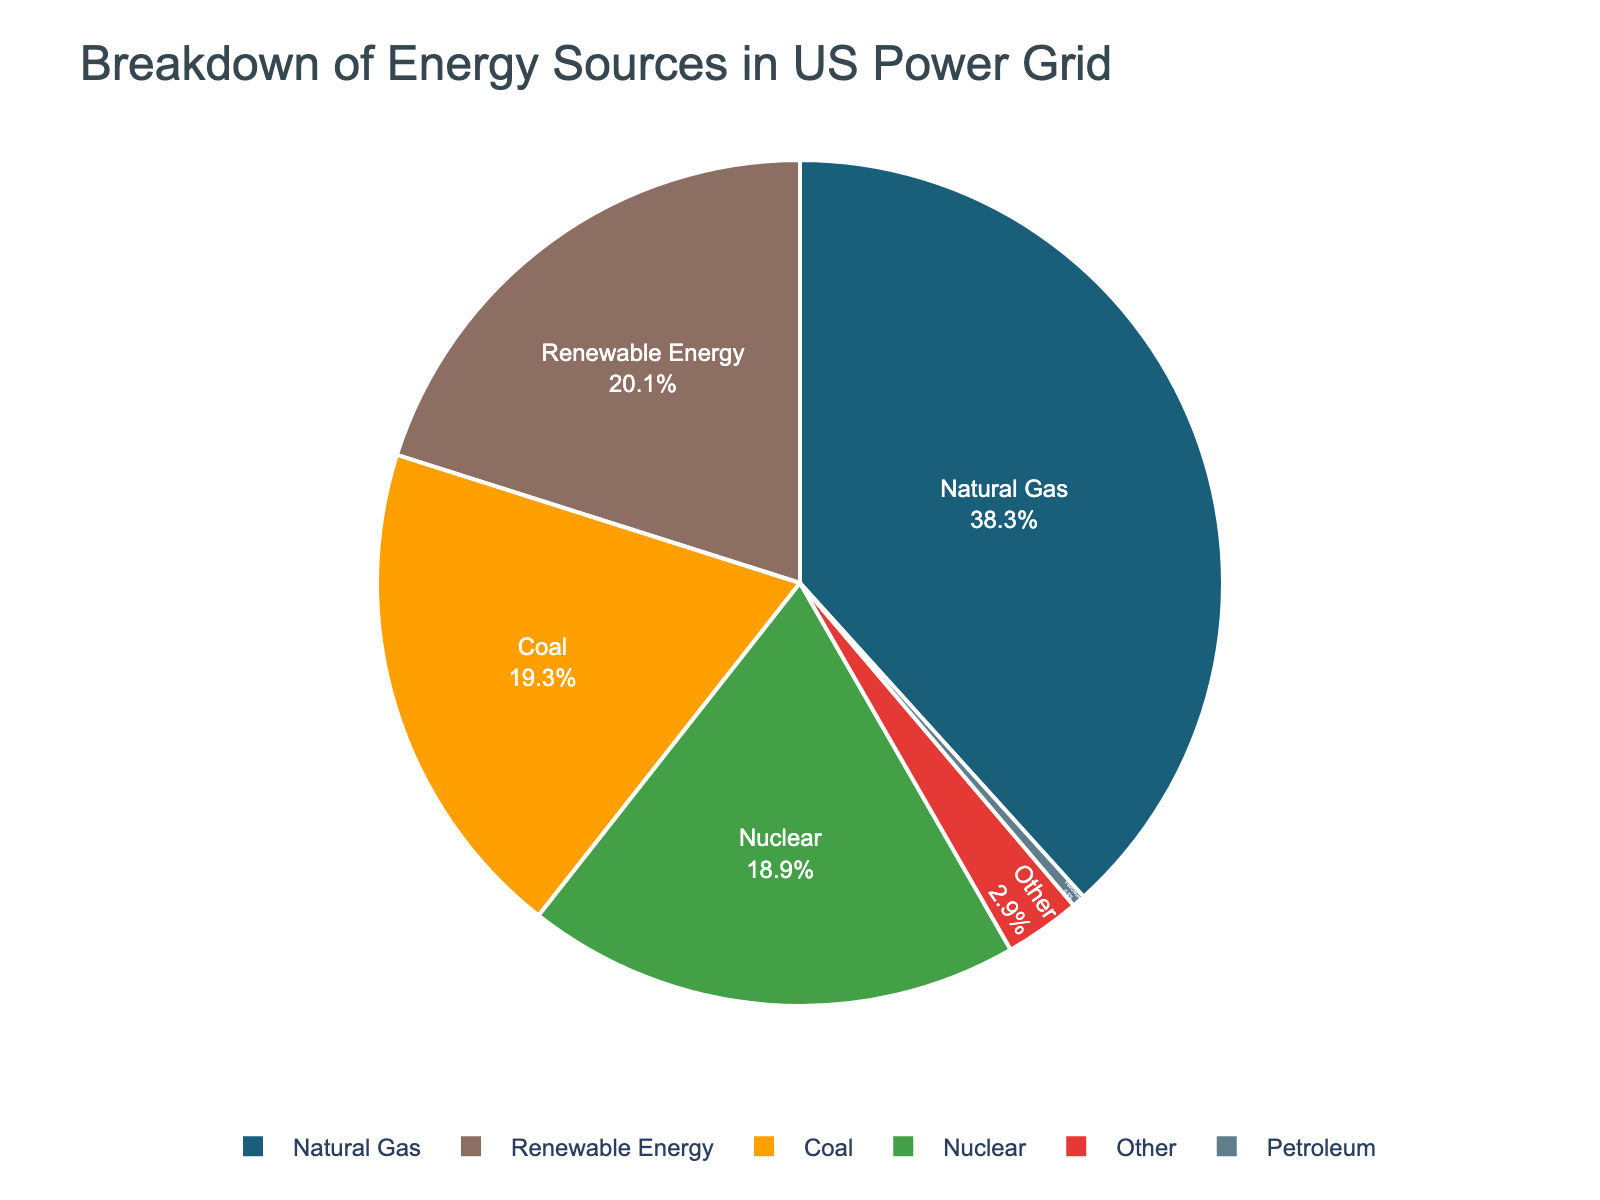What's the predominant energy source in the US power grid? By looking at the pie chart, identify which segment represents more than the others based on its size and color. Here, Natural Gas occupies the largest segment.
Answer: Natural Gas What's the combined percentage of energy provided by Coal and Nuclear sources? Add the percentages of Coal and Nuclear sources from the pie chart: 19.3% (Coal) + 18.9% (Nuclear).
Answer: 38.2% Which energy source contributes the least to the US power grid? Look for the smallest slice in the pie chart. The slice representing Petroleum is the smallest with 0.5%.
Answer: Petroleum How much more does Renewable Energy contribute compared to Coal? Subtract the percentage of Coal from the percentage of Renewable Energy: 20.1% - 19.3%.
Answer: 0.8% What is the total percentage of non-renewable energy sources (Natural Gas, Coal, Petroleum, Other)? Add the percentages of Natural Gas, Coal, Petroleum, and Other: 38.3% + 19.3% + 0.5% + 2.9%.
Answer: 61.0% Which energy source is closest in contribution to Nuclear Energy? Compare percentage values of all sources to Nuclear (18.9%). Renewable Energy (20.1%) is the closest to Nuclear Energy.
Answer: Renewable Energy Among Renewable Energy and Natural Gas, which one has a higher contribution and by how much? Subtract the percentage of Renewable Energy from that of Natural Gas: 38.3% - 20.1%.
Answer: Natural Gas by 18.2% What's the average contribution of Nuclear and Renewable Energy? Add the percentages of Nuclear and Renewable Energy and then divide by 2: (18.9% + 20.1%) / 2.
Answer: 19.5% If you combine Nuclear and Renewable Energy contributions, do they account for more than Natural Gas? Add the percentages of Nuclear and Renewable Energy and compare to Natural Gas: 18.9% + 20.1% = 39%, which is greater than 38.3%.
Answer: Yes, they do What proportion of the energy sources is non-fossil based (Nuclear and Renewable Energy)? Add the percentages of Nuclear Energy and Renewable Energy and compare it to the total percentage: 18.9% + 20.1%.
Answer: 39.0% 